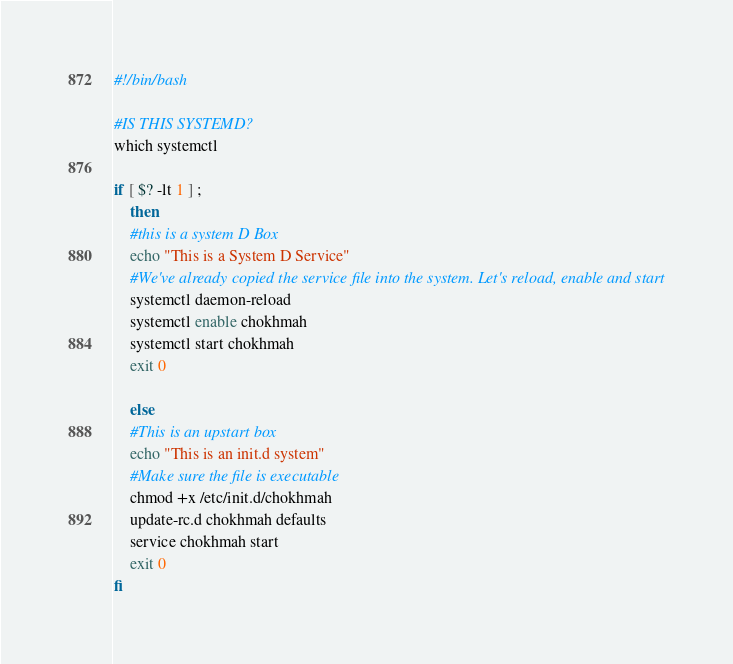Convert code to text. <code><loc_0><loc_0><loc_500><loc_500><_Bash_>#!/bin/bash

#IS THIS SYSTEMD?
which systemctl

if [ $? -lt 1 ] ;
    then
    #this is a system D Box
    echo "This is a System D Service"
    #We've already copied the service file into the system. Let's reload, enable and start
    systemctl daemon-reload
    systemctl enable chokhmah
    systemctl start chokhmah
    exit 0 

    else
    #This is an upstart box
    echo "This is an init.d system"
    #Make sure the file is executable
    chmod +x /etc/init.d/chokhmah
    update-rc.d chokhmah defaults
    service chokhmah start
    exit 0
fi</code> 